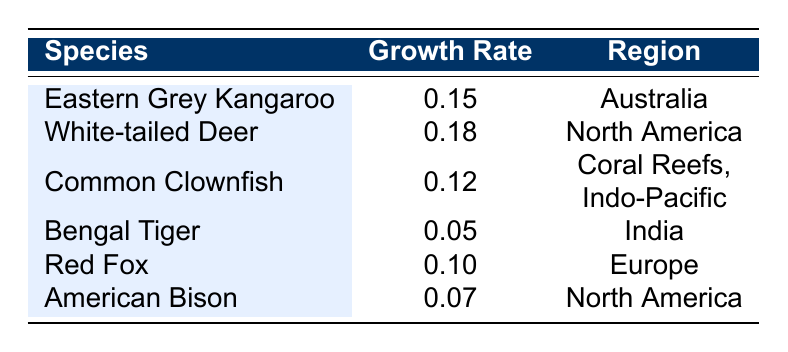What is the growth rate of the Eastern Grey Kangaroo? The table lists the growth rate of the Eastern Grey Kangaroo in the corresponding row, which is 0.15.
Answer: 0.15 Which species has the highest growth rate? By examining the growth rates in the table, the White-tailed Deer has the highest growth rate of 0.18.
Answer: White-tailed Deer What is the average growth rate of North American species? There are two species from North America: White-tailed Deer (0.18) and American Bison (0.07). First, sum up the growth rates: 0.18 + 0.07 = 0.25. Then divide by the number of species: 0.25 / 2 = 0.125.
Answer: 0.125 Is the growth rate of the Bengal Tiger greater than 0.1? The growth rate of the Bengal Tiger is listed as 0.05, which is less than 0.1 in the table.
Answer: No Which species has the lowest growth rate, and what is it? Looking at the growth rates in the table, the Bengal Tiger has the lowest growth rate of 0.05.
Answer: Bengal Tiger, 0.05 How many species listed have a growth rate greater than 0.1? The species with growth rates greater than 0.1 are the Eastern Grey Kangaroo (0.15), White-tailed Deer (0.18), and Common Clownfish (0.12). Counting these, there are three species.
Answer: 3 What is the difference between the highest and lowest growth rates in the table? The highest growth rate is 0.18 (White-tailed Deer) and the lowest is 0.05 (Bengal Tiger). Subtracting these values gives: 0.18 - 0.05 = 0.13.
Answer: 0.13 Are there any species with a growth rate of exactly 0.1? Checking the table, the Red Fox has a growth rate of exactly 0.10. Therefore, the answer is yes.
Answer: Yes 